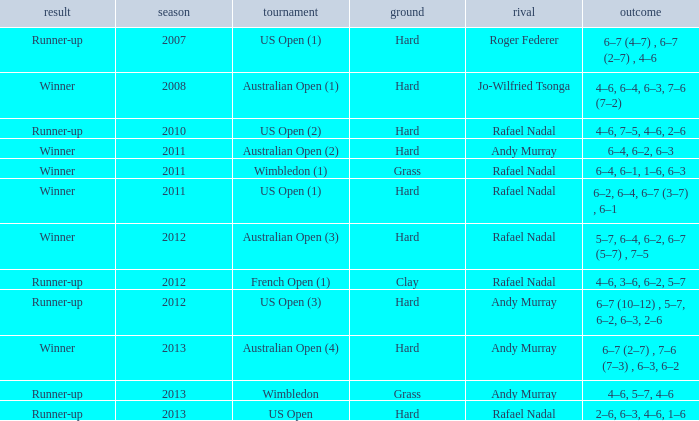What is the outcome of the 4–6, 6–4, 6–3, 7–6 (7–2) score? Winner. 